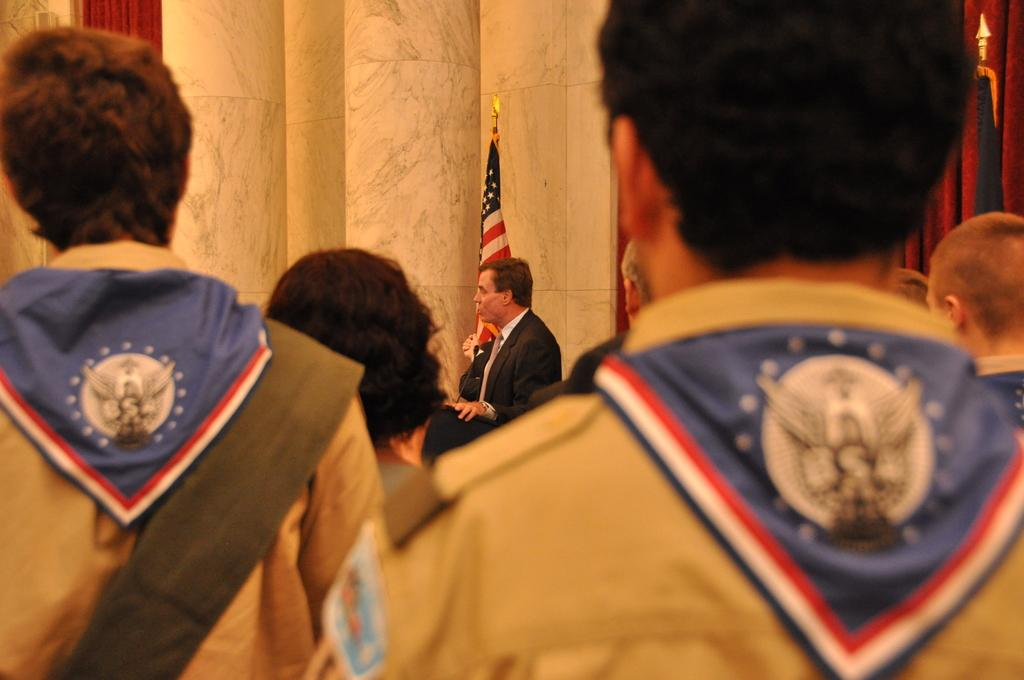What are the people in the image doing? The people in the image are standing with their backs facing the viewer. Can you describe the person in the center of the image? The person in the center of the image is wearing a suit. What is present in the image besides the people? There is a flag and pillars in the background of the image. What type of knot is being tied by the person in the image? There is no knot-tying activity depicted in the image. Can you see a jar on the person's head in the image? There is no jar present on anyone's head in the image. 